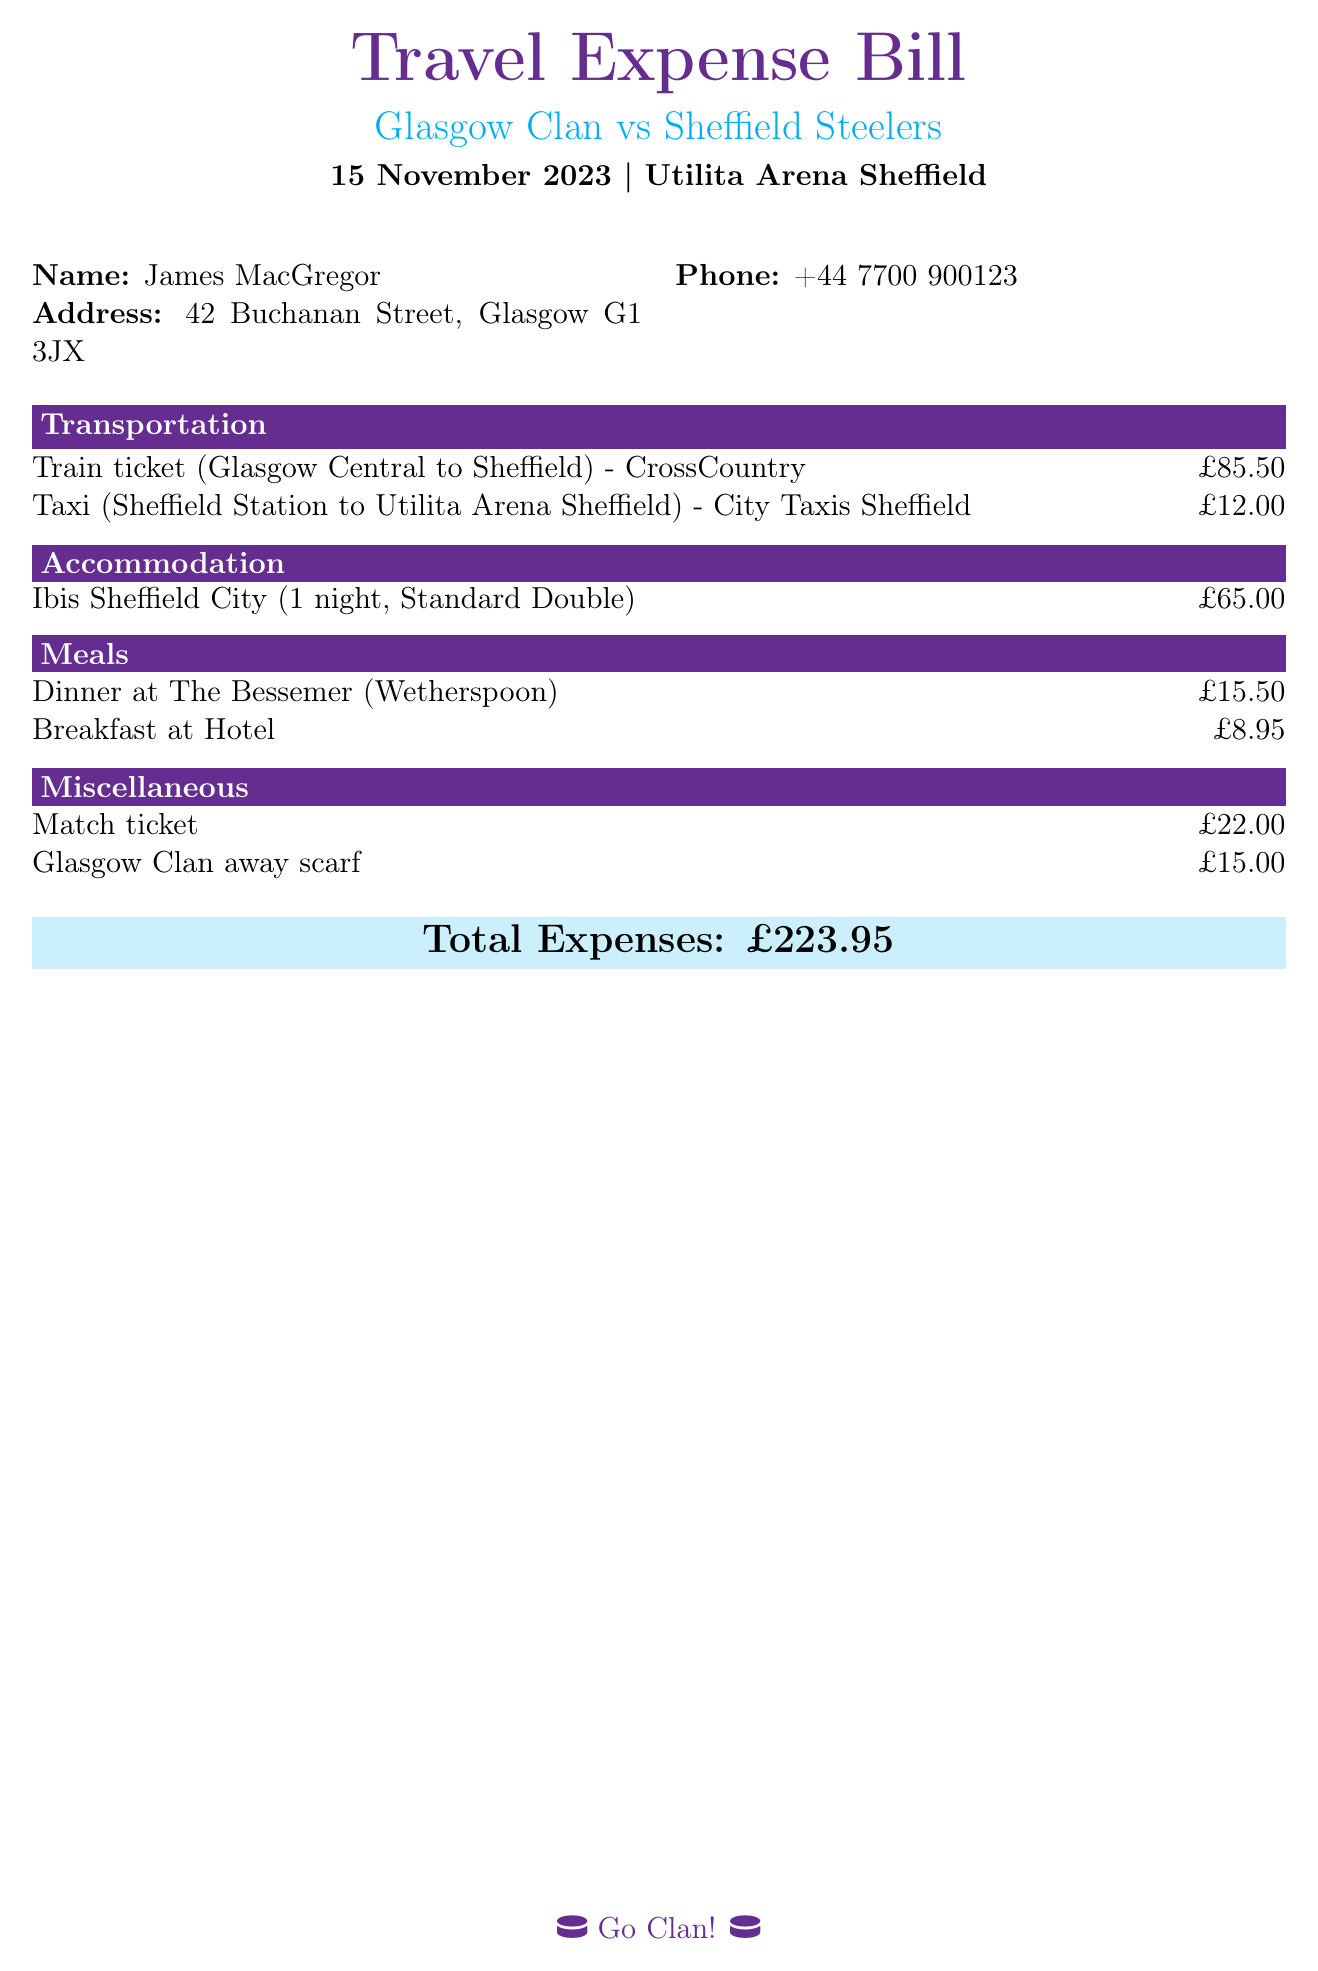What is the date of the game? The date of the game is stated clearly in the header of the document.
Answer: 15 November 2023 Who is the claimant's contact person? The document lists the person's name and phone number in the contact section.
Answer: James MacGregor What is the cost of the train ticket? The cost is specified under the transportation section of the document.
Answer: £85.50 How much was spent on accommodation? The accommodation cost is clearly detailed in the accommodation section.
Answer: £65.00 What is the total expense? The total expense is provided in the summary section of the document.
Answer: £223.95 How much did the match ticket cost? The cost of the match ticket is listed under the miscellaneous section.
Answer: £22.00 What type of accommodation was booked? The type of accommodation is mentioned in the accommodation section detailing the hotel and room type.
Answer: Standard Double How much was spent on meals? The total meals expenditure can be calculated by summing the costs listed under the meals section.
Answer: £24.45 What transportation method was used to get to the arena? The transportation section specifies the method used to travel to the arena.
Answer: Taxi 